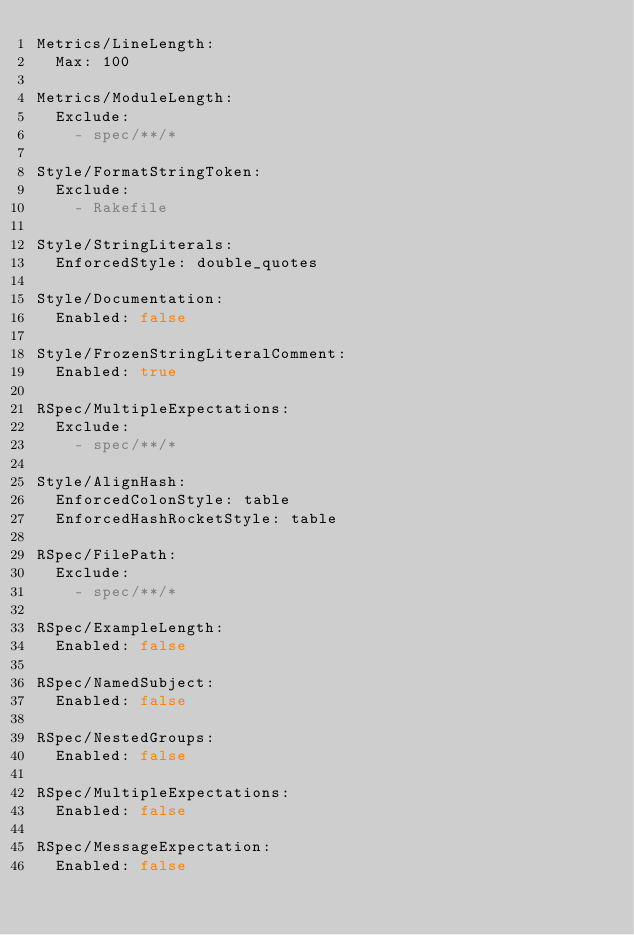<code> <loc_0><loc_0><loc_500><loc_500><_YAML_>Metrics/LineLength:
  Max: 100

Metrics/ModuleLength:
  Exclude:
    - spec/**/*

Style/FormatStringToken:
  Exclude:
    - Rakefile

Style/StringLiterals:
  EnforcedStyle: double_quotes

Style/Documentation:
  Enabled: false

Style/FrozenStringLiteralComment:
  Enabled: true

RSpec/MultipleExpectations:
  Exclude:
    - spec/**/*

Style/AlignHash:
  EnforcedColonStyle: table
  EnforcedHashRocketStyle: table

RSpec/FilePath:
  Exclude:
    - spec/**/*

RSpec/ExampleLength:
  Enabled: false

RSpec/NamedSubject:
  Enabled: false

RSpec/NestedGroups:
  Enabled: false

RSpec/MultipleExpectations:
  Enabled: false

RSpec/MessageExpectation:
  Enabled: false
</code> 